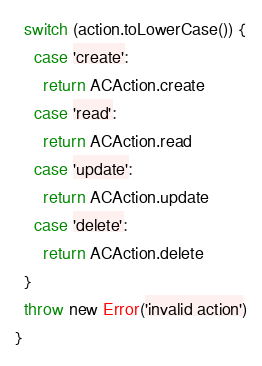Convert code to text. <code><loc_0><loc_0><loc_500><loc_500><_TypeScript_>  switch (action.toLowerCase()) {
    case 'create':
      return ACAction.create
    case 'read':
      return ACAction.read
    case 'update':
      return ACAction.update
    case 'delete':
      return ACAction.delete
  }
  throw new Error('invalid action')
}
</code> 